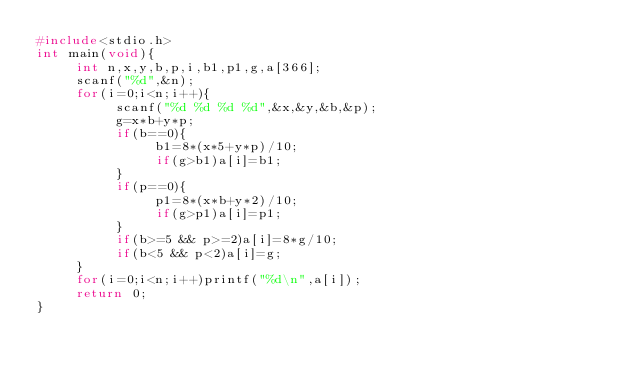Convert code to text. <code><loc_0><loc_0><loc_500><loc_500><_C_>#include<stdio.h>
int main(void){
     int n,x,y,b,p,i,b1,p1,g,a[366];
     scanf("%d",&n);
     for(i=0;i<n;i++){
          scanf("%d %d %d %d",&x,&y,&b,&p);
          g=x*b+y*p;
          if(b==0){
               b1=8*(x*5+y*p)/10;
               if(g>b1)a[i]=b1;
          }
          if(p==0){
               p1=8*(x*b+y*2)/10;
               if(g>p1)a[i]=p1;
          }
          if(b>=5 && p>=2)a[i]=8*g/10;
          if(b<5 && p<2)a[i]=g;
     }
     for(i=0;i<n;i++)printf("%d\n",a[i]);
     return 0;
}</code> 